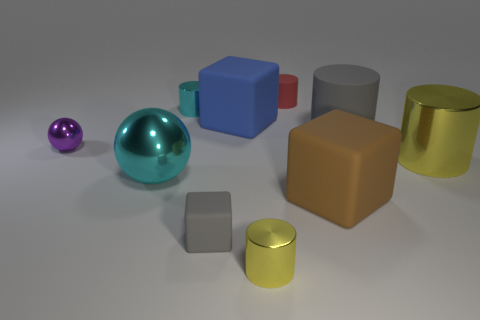Subtract all tiny cubes. How many cubes are left? 2 Subtract all green cubes. How many yellow cylinders are left? 2 Subtract all cubes. How many objects are left? 7 Subtract 1 blocks. How many blocks are left? 2 Subtract all brown blocks. How many blocks are left? 2 Add 5 big gray cylinders. How many big gray cylinders are left? 6 Add 5 tiny green shiny cylinders. How many tiny green shiny cylinders exist? 5 Subtract 0 cyan blocks. How many objects are left? 10 Subtract all green blocks. Subtract all purple cylinders. How many blocks are left? 3 Subtract all big yellow cylinders. Subtract all purple metal spheres. How many objects are left? 8 